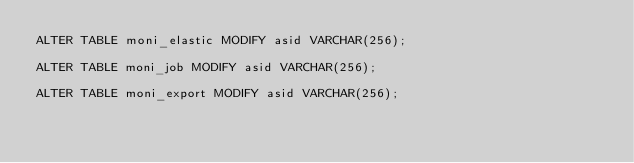Convert code to text. <code><loc_0><loc_0><loc_500><loc_500><_SQL_>ALTER TABLE moni_elastic MODIFY asid VARCHAR(256);

ALTER TABLE moni_job MODIFY asid VARCHAR(256);

ALTER TABLE moni_export MODIFY asid VARCHAR(256);</code> 